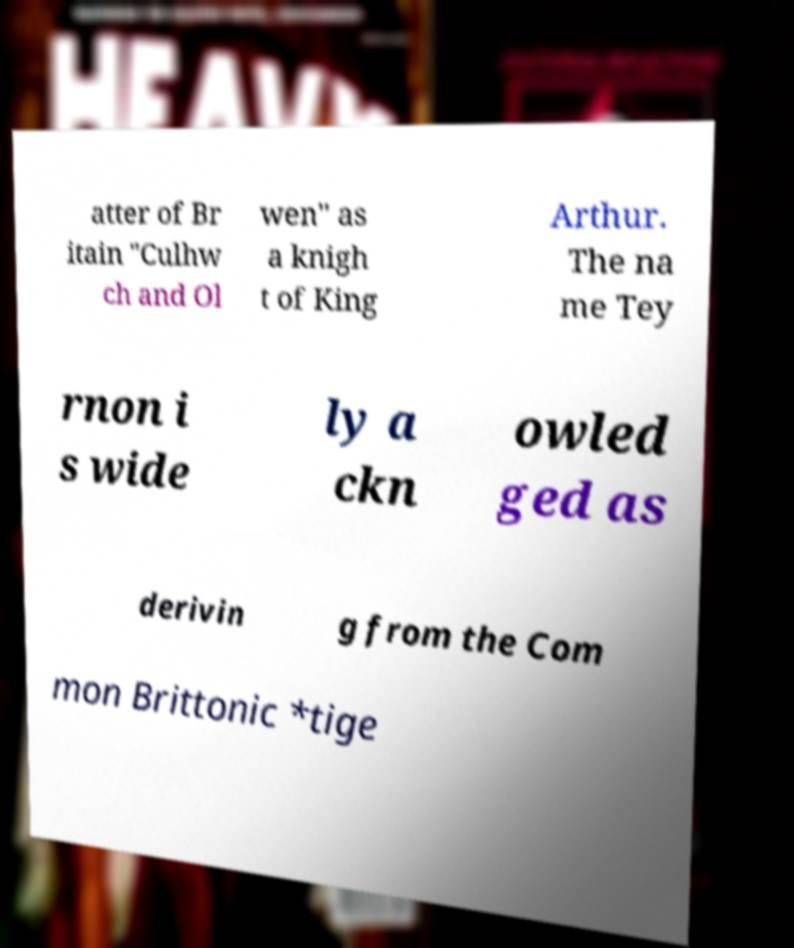There's text embedded in this image that I need extracted. Can you transcribe it verbatim? atter of Br itain "Culhw ch and Ol wen" as a knigh t of King Arthur. The na me Tey rnon i s wide ly a ckn owled ged as derivin g from the Com mon Brittonic *tige 